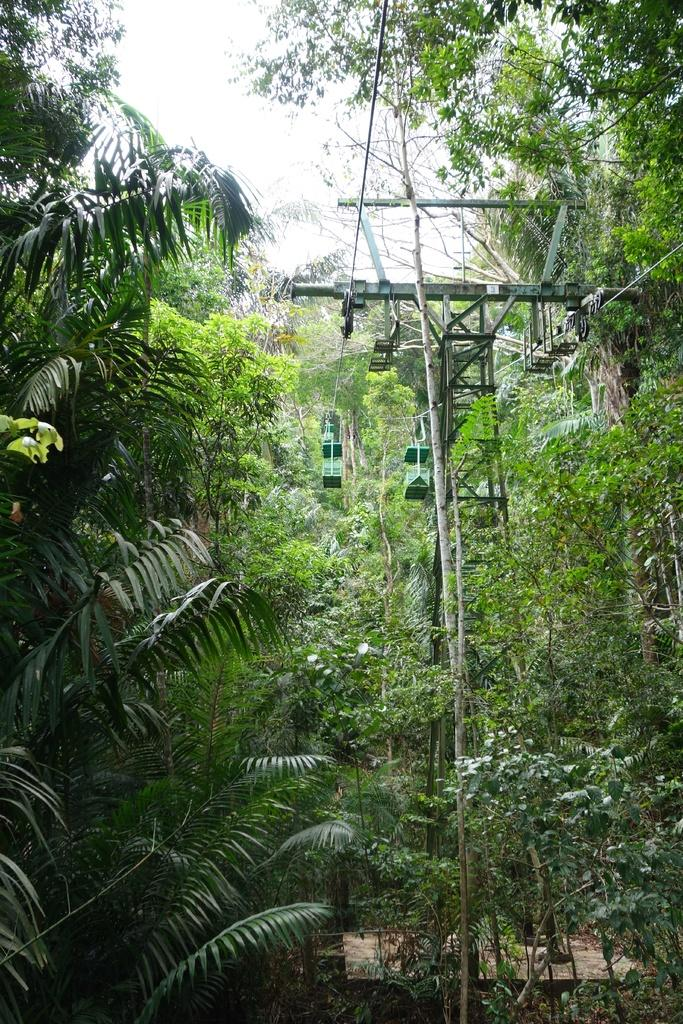What type of vegetation can be seen in the image? There are trees in the image. What structure is present in the image? There is a tower in the image. What else can be seen in the image besides trees and the tower? There is a wire in the image. What is visible at the top of the image? The sky is visible at the top of the image. How many committee members are visible in the image? There is no committee or committee members present in the image. What type of corn can be seen growing near the tower in the image? There is no corn present in the image; it only features trees, a tower, a wire, and the sky. 